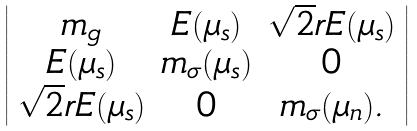Convert formula to latex. <formula><loc_0><loc_0><loc_500><loc_500>\left | \begin{array} { c c c } m _ { g } & E ( \mu _ { s } ) & \sqrt { 2 } r E ( \mu _ { s } ) \\ E ( \mu _ { s } ) & m _ { \sigma } ( \mu _ { s } ) & 0 \\ \sqrt { 2 } r E ( \mu _ { s } ) & 0 & m _ { \sigma } ( \mu _ { n } ) . \end{array} \right |</formula> 